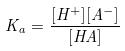<formula> <loc_0><loc_0><loc_500><loc_500>K _ { a } = \frac { [ H ^ { + } ] [ A ^ { - } ] } { [ H A ] }</formula> 